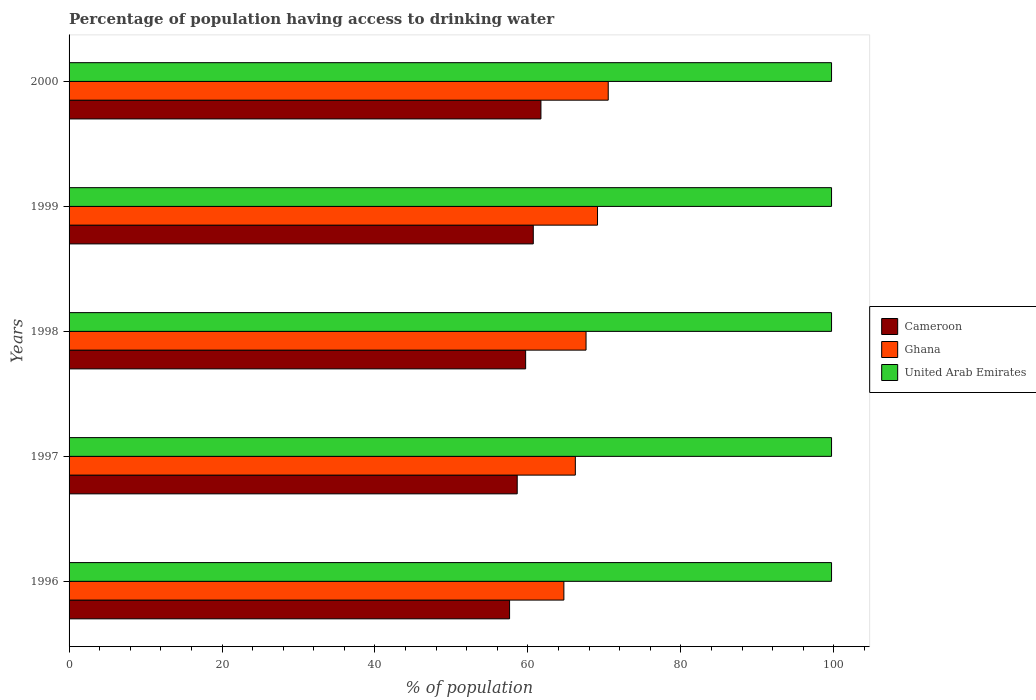How many different coloured bars are there?
Give a very brief answer. 3. Are the number of bars per tick equal to the number of legend labels?
Your answer should be compact. Yes. Are the number of bars on each tick of the Y-axis equal?
Offer a terse response. Yes. In how many cases, is the number of bars for a given year not equal to the number of legend labels?
Offer a terse response. 0. What is the percentage of population having access to drinking water in Cameroon in 1996?
Your response must be concise. 57.6. Across all years, what is the maximum percentage of population having access to drinking water in Cameroon?
Ensure brevity in your answer.  61.7. Across all years, what is the minimum percentage of population having access to drinking water in United Arab Emirates?
Provide a short and direct response. 99.7. In which year was the percentage of population having access to drinking water in Ghana maximum?
Offer a terse response. 2000. In which year was the percentage of population having access to drinking water in Cameroon minimum?
Your answer should be compact. 1996. What is the total percentage of population having access to drinking water in United Arab Emirates in the graph?
Your response must be concise. 498.5. What is the difference between the percentage of population having access to drinking water in Cameroon in 1997 and that in 1999?
Your answer should be compact. -2.1. What is the difference between the percentage of population having access to drinking water in Ghana in 1998 and the percentage of population having access to drinking water in Cameroon in 1999?
Provide a succinct answer. 6.9. What is the average percentage of population having access to drinking water in Ghana per year?
Offer a terse response. 67.62. In the year 1998, what is the difference between the percentage of population having access to drinking water in Ghana and percentage of population having access to drinking water in United Arab Emirates?
Make the answer very short. -32.1. In how many years, is the percentage of population having access to drinking water in Cameroon greater than 48 %?
Ensure brevity in your answer.  5. What is the ratio of the percentage of population having access to drinking water in United Arab Emirates in 1997 to that in 1998?
Offer a terse response. 1. Is the difference between the percentage of population having access to drinking water in Ghana in 1996 and 2000 greater than the difference between the percentage of population having access to drinking water in United Arab Emirates in 1996 and 2000?
Offer a terse response. No. What is the difference between the highest and the lowest percentage of population having access to drinking water in United Arab Emirates?
Offer a very short reply. 0. In how many years, is the percentage of population having access to drinking water in United Arab Emirates greater than the average percentage of population having access to drinking water in United Arab Emirates taken over all years?
Keep it short and to the point. 0. Is the sum of the percentage of population having access to drinking water in Cameroon in 1996 and 2000 greater than the maximum percentage of population having access to drinking water in United Arab Emirates across all years?
Make the answer very short. Yes. What does the 1st bar from the top in 1997 represents?
Provide a short and direct response. United Arab Emirates. What does the 2nd bar from the bottom in 1997 represents?
Provide a short and direct response. Ghana. Is it the case that in every year, the sum of the percentage of population having access to drinking water in United Arab Emirates and percentage of population having access to drinking water in Ghana is greater than the percentage of population having access to drinking water in Cameroon?
Provide a short and direct response. Yes. What is the difference between two consecutive major ticks on the X-axis?
Keep it short and to the point. 20. Does the graph contain any zero values?
Provide a succinct answer. No. How many legend labels are there?
Provide a short and direct response. 3. How are the legend labels stacked?
Offer a very short reply. Vertical. What is the title of the graph?
Offer a terse response. Percentage of population having access to drinking water. What is the label or title of the X-axis?
Your response must be concise. % of population. What is the label or title of the Y-axis?
Offer a very short reply. Years. What is the % of population of Cameroon in 1996?
Provide a short and direct response. 57.6. What is the % of population in Ghana in 1996?
Keep it short and to the point. 64.7. What is the % of population in United Arab Emirates in 1996?
Make the answer very short. 99.7. What is the % of population of Cameroon in 1997?
Offer a terse response. 58.6. What is the % of population of Ghana in 1997?
Provide a short and direct response. 66.2. What is the % of population in United Arab Emirates in 1997?
Provide a succinct answer. 99.7. What is the % of population in Cameroon in 1998?
Your response must be concise. 59.7. What is the % of population of Ghana in 1998?
Offer a terse response. 67.6. What is the % of population in United Arab Emirates in 1998?
Your response must be concise. 99.7. What is the % of population in Cameroon in 1999?
Your response must be concise. 60.7. What is the % of population in Ghana in 1999?
Provide a succinct answer. 69.1. What is the % of population of United Arab Emirates in 1999?
Your response must be concise. 99.7. What is the % of population in Cameroon in 2000?
Your response must be concise. 61.7. What is the % of population in Ghana in 2000?
Offer a very short reply. 70.5. What is the % of population in United Arab Emirates in 2000?
Offer a terse response. 99.7. Across all years, what is the maximum % of population of Cameroon?
Ensure brevity in your answer.  61.7. Across all years, what is the maximum % of population in Ghana?
Your answer should be compact. 70.5. Across all years, what is the maximum % of population of United Arab Emirates?
Keep it short and to the point. 99.7. Across all years, what is the minimum % of population in Cameroon?
Your answer should be very brief. 57.6. Across all years, what is the minimum % of population in Ghana?
Provide a succinct answer. 64.7. Across all years, what is the minimum % of population of United Arab Emirates?
Your response must be concise. 99.7. What is the total % of population of Cameroon in the graph?
Ensure brevity in your answer.  298.3. What is the total % of population of Ghana in the graph?
Provide a short and direct response. 338.1. What is the total % of population in United Arab Emirates in the graph?
Make the answer very short. 498.5. What is the difference between the % of population in United Arab Emirates in 1996 and that in 1997?
Give a very brief answer. 0. What is the difference between the % of population of Cameroon in 1996 and that in 1998?
Provide a succinct answer. -2.1. What is the difference between the % of population in United Arab Emirates in 1996 and that in 1998?
Give a very brief answer. 0. What is the difference between the % of population in Ghana in 1996 and that in 1999?
Provide a short and direct response. -4.4. What is the difference between the % of population in United Arab Emirates in 1996 and that in 1999?
Ensure brevity in your answer.  0. What is the difference between the % of population in Cameroon in 1996 and that in 2000?
Your response must be concise. -4.1. What is the difference between the % of population of Ghana in 1997 and that in 1998?
Offer a very short reply. -1.4. What is the difference between the % of population in Cameroon in 1997 and that in 1999?
Offer a very short reply. -2.1. What is the difference between the % of population of United Arab Emirates in 1997 and that in 1999?
Make the answer very short. 0. What is the difference between the % of population in Ghana in 1997 and that in 2000?
Your answer should be compact. -4.3. What is the difference between the % of population in Ghana in 1998 and that in 1999?
Provide a short and direct response. -1.5. What is the difference between the % of population in Cameroon in 1998 and that in 2000?
Ensure brevity in your answer.  -2. What is the difference between the % of population of Ghana in 1998 and that in 2000?
Your answer should be very brief. -2.9. What is the difference between the % of population of Ghana in 1999 and that in 2000?
Your answer should be very brief. -1.4. What is the difference between the % of population in United Arab Emirates in 1999 and that in 2000?
Ensure brevity in your answer.  0. What is the difference between the % of population of Cameroon in 1996 and the % of population of Ghana in 1997?
Your answer should be very brief. -8.6. What is the difference between the % of population of Cameroon in 1996 and the % of population of United Arab Emirates in 1997?
Ensure brevity in your answer.  -42.1. What is the difference between the % of population in Ghana in 1996 and the % of population in United Arab Emirates in 1997?
Your answer should be very brief. -35. What is the difference between the % of population in Cameroon in 1996 and the % of population in Ghana in 1998?
Your answer should be very brief. -10. What is the difference between the % of population in Cameroon in 1996 and the % of population in United Arab Emirates in 1998?
Give a very brief answer. -42.1. What is the difference between the % of population in Ghana in 1996 and the % of population in United Arab Emirates in 1998?
Provide a short and direct response. -35. What is the difference between the % of population of Cameroon in 1996 and the % of population of United Arab Emirates in 1999?
Provide a short and direct response. -42.1. What is the difference between the % of population in Ghana in 1996 and the % of population in United Arab Emirates in 1999?
Ensure brevity in your answer.  -35. What is the difference between the % of population in Cameroon in 1996 and the % of population in United Arab Emirates in 2000?
Make the answer very short. -42.1. What is the difference between the % of population of Ghana in 1996 and the % of population of United Arab Emirates in 2000?
Your answer should be compact. -35. What is the difference between the % of population of Cameroon in 1997 and the % of population of Ghana in 1998?
Ensure brevity in your answer.  -9. What is the difference between the % of population of Cameroon in 1997 and the % of population of United Arab Emirates in 1998?
Provide a succinct answer. -41.1. What is the difference between the % of population of Ghana in 1997 and the % of population of United Arab Emirates in 1998?
Keep it short and to the point. -33.5. What is the difference between the % of population in Cameroon in 1997 and the % of population in Ghana in 1999?
Provide a succinct answer. -10.5. What is the difference between the % of population in Cameroon in 1997 and the % of population in United Arab Emirates in 1999?
Give a very brief answer. -41.1. What is the difference between the % of population of Ghana in 1997 and the % of population of United Arab Emirates in 1999?
Your answer should be very brief. -33.5. What is the difference between the % of population in Cameroon in 1997 and the % of population in Ghana in 2000?
Provide a short and direct response. -11.9. What is the difference between the % of population of Cameroon in 1997 and the % of population of United Arab Emirates in 2000?
Make the answer very short. -41.1. What is the difference between the % of population of Ghana in 1997 and the % of population of United Arab Emirates in 2000?
Your response must be concise. -33.5. What is the difference between the % of population of Cameroon in 1998 and the % of population of Ghana in 1999?
Offer a terse response. -9.4. What is the difference between the % of population of Ghana in 1998 and the % of population of United Arab Emirates in 1999?
Offer a terse response. -32.1. What is the difference between the % of population of Ghana in 1998 and the % of population of United Arab Emirates in 2000?
Your answer should be very brief. -32.1. What is the difference between the % of population of Cameroon in 1999 and the % of population of Ghana in 2000?
Keep it short and to the point. -9.8. What is the difference between the % of population of Cameroon in 1999 and the % of population of United Arab Emirates in 2000?
Your answer should be very brief. -39. What is the difference between the % of population in Ghana in 1999 and the % of population in United Arab Emirates in 2000?
Your answer should be very brief. -30.6. What is the average % of population in Cameroon per year?
Give a very brief answer. 59.66. What is the average % of population in Ghana per year?
Provide a short and direct response. 67.62. What is the average % of population of United Arab Emirates per year?
Keep it short and to the point. 99.7. In the year 1996, what is the difference between the % of population of Cameroon and % of population of United Arab Emirates?
Give a very brief answer. -42.1. In the year 1996, what is the difference between the % of population in Ghana and % of population in United Arab Emirates?
Provide a short and direct response. -35. In the year 1997, what is the difference between the % of population in Cameroon and % of population in United Arab Emirates?
Provide a short and direct response. -41.1. In the year 1997, what is the difference between the % of population of Ghana and % of population of United Arab Emirates?
Offer a terse response. -33.5. In the year 1998, what is the difference between the % of population of Cameroon and % of population of United Arab Emirates?
Offer a very short reply. -40. In the year 1998, what is the difference between the % of population of Ghana and % of population of United Arab Emirates?
Make the answer very short. -32.1. In the year 1999, what is the difference between the % of population of Cameroon and % of population of Ghana?
Keep it short and to the point. -8.4. In the year 1999, what is the difference between the % of population of Cameroon and % of population of United Arab Emirates?
Your answer should be very brief. -39. In the year 1999, what is the difference between the % of population in Ghana and % of population in United Arab Emirates?
Offer a very short reply. -30.6. In the year 2000, what is the difference between the % of population in Cameroon and % of population in Ghana?
Ensure brevity in your answer.  -8.8. In the year 2000, what is the difference between the % of population in Cameroon and % of population in United Arab Emirates?
Your response must be concise. -38. In the year 2000, what is the difference between the % of population in Ghana and % of population in United Arab Emirates?
Offer a very short reply. -29.2. What is the ratio of the % of population in Cameroon in 1996 to that in 1997?
Provide a succinct answer. 0.98. What is the ratio of the % of population of Ghana in 1996 to that in 1997?
Your answer should be very brief. 0.98. What is the ratio of the % of population in United Arab Emirates in 1996 to that in 1997?
Keep it short and to the point. 1. What is the ratio of the % of population in Cameroon in 1996 to that in 1998?
Provide a succinct answer. 0.96. What is the ratio of the % of population in Ghana in 1996 to that in 1998?
Offer a very short reply. 0.96. What is the ratio of the % of population in United Arab Emirates in 1996 to that in 1998?
Make the answer very short. 1. What is the ratio of the % of population of Cameroon in 1996 to that in 1999?
Your response must be concise. 0.95. What is the ratio of the % of population of Ghana in 1996 to that in 1999?
Offer a terse response. 0.94. What is the ratio of the % of population in Cameroon in 1996 to that in 2000?
Your answer should be very brief. 0.93. What is the ratio of the % of population in Ghana in 1996 to that in 2000?
Offer a terse response. 0.92. What is the ratio of the % of population in Cameroon in 1997 to that in 1998?
Provide a succinct answer. 0.98. What is the ratio of the % of population in Ghana in 1997 to that in 1998?
Provide a succinct answer. 0.98. What is the ratio of the % of population in Cameroon in 1997 to that in 1999?
Your answer should be very brief. 0.97. What is the ratio of the % of population in Ghana in 1997 to that in 1999?
Give a very brief answer. 0.96. What is the ratio of the % of population of United Arab Emirates in 1997 to that in 1999?
Provide a short and direct response. 1. What is the ratio of the % of population of Cameroon in 1997 to that in 2000?
Ensure brevity in your answer.  0.95. What is the ratio of the % of population of Ghana in 1997 to that in 2000?
Your response must be concise. 0.94. What is the ratio of the % of population of United Arab Emirates in 1997 to that in 2000?
Give a very brief answer. 1. What is the ratio of the % of population of Cameroon in 1998 to that in 1999?
Offer a terse response. 0.98. What is the ratio of the % of population of Ghana in 1998 to that in 1999?
Keep it short and to the point. 0.98. What is the ratio of the % of population in Cameroon in 1998 to that in 2000?
Make the answer very short. 0.97. What is the ratio of the % of population in Ghana in 1998 to that in 2000?
Your answer should be compact. 0.96. What is the ratio of the % of population in United Arab Emirates in 1998 to that in 2000?
Give a very brief answer. 1. What is the ratio of the % of population in Cameroon in 1999 to that in 2000?
Provide a short and direct response. 0.98. What is the ratio of the % of population in Ghana in 1999 to that in 2000?
Provide a succinct answer. 0.98. What is the ratio of the % of population of United Arab Emirates in 1999 to that in 2000?
Your answer should be compact. 1. What is the difference between the highest and the second highest % of population in United Arab Emirates?
Give a very brief answer. 0. What is the difference between the highest and the lowest % of population of United Arab Emirates?
Your answer should be compact. 0. 